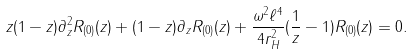<formula> <loc_0><loc_0><loc_500><loc_500>z ( 1 - z ) \partial _ { z } ^ { 2 } R _ { ( 0 ) } ( z ) + ( 1 - z ) \partial _ { z } R _ { ( 0 ) } ( z ) + \frac { \omega ^ { 2 } \ell ^ { 4 } } { 4 r _ { H } ^ { 2 } } ( \frac { 1 } { z } - 1 ) R _ { ( 0 ) } ( z ) = 0 .</formula> 